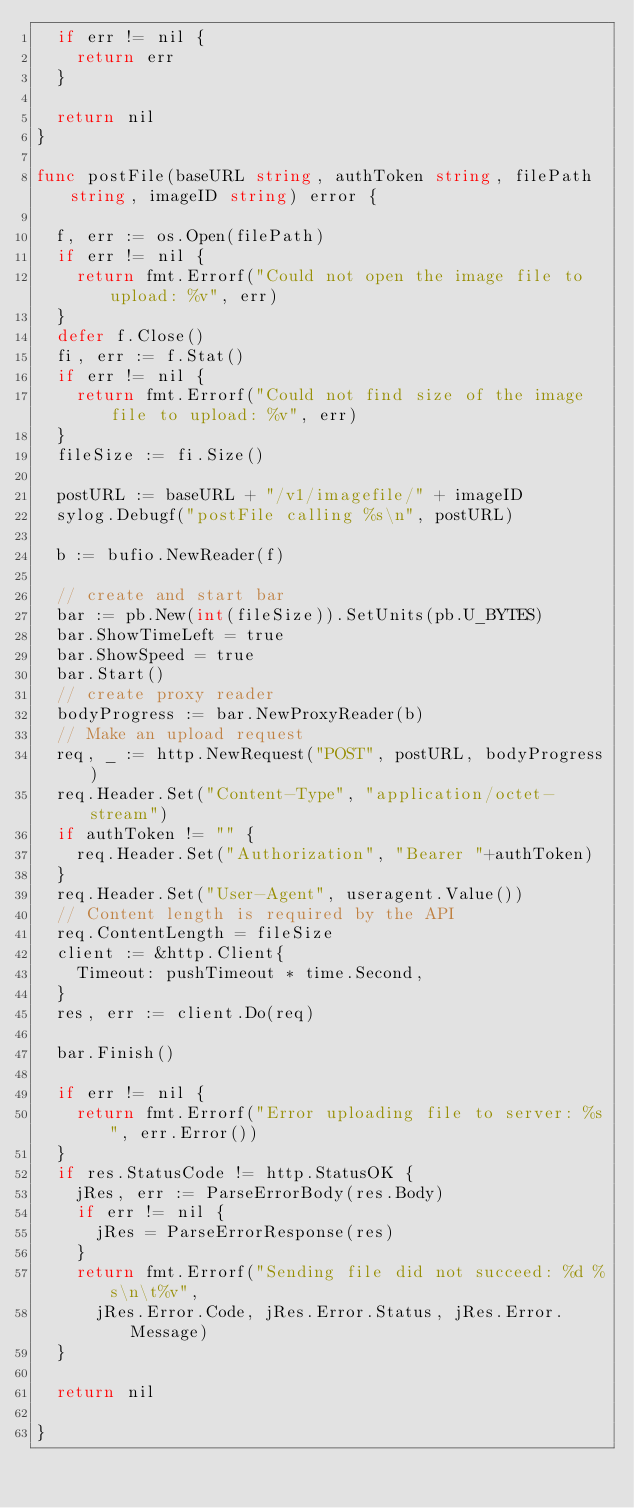<code> <loc_0><loc_0><loc_500><loc_500><_Go_>	if err != nil {
		return err
	}

	return nil
}

func postFile(baseURL string, authToken string, filePath string, imageID string) error {

	f, err := os.Open(filePath)
	if err != nil {
		return fmt.Errorf("Could not open the image file to upload: %v", err)
	}
	defer f.Close()
	fi, err := f.Stat()
	if err != nil {
		return fmt.Errorf("Could not find size of the image file to upload: %v", err)
	}
	fileSize := fi.Size()

	postURL := baseURL + "/v1/imagefile/" + imageID
	sylog.Debugf("postFile calling %s\n", postURL)

	b := bufio.NewReader(f)

	// create and start bar
	bar := pb.New(int(fileSize)).SetUnits(pb.U_BYTES)
	bar.ShowTimeLeft = true
	bar.ShowSpeed = true
	bar.Start()
	// create proxy reader
	bodyProgress := bar.NewProxyReader(b)
	// Make an upload request
	req, _ := http.NewRequest("POST", postURL, bodyProgress)
	req.Header.Set("Content-Type", "application/octet-stream")
	if authToken != "" {
		req.Header.Set("Authorization", "Bearer "+authToken)
	}
	req.Header.Set("User-Agent", useragent.Value())
	// Content length is required by the API
	req.ContentLength = fileSize
	client := &http.Client{
		Timeout: pushTimeout * time.Second,
	}
	res, err := client.Do(req)

	bar.Finish()

	if err != nil {
		return fmt.Errorf("Error uploading file to server: %s", err.Error())
	}
	if res.StatusCode != http.StatusOK {
		jRes, err := ParseErrorBody(res.Body)
		if err != nil {
			jRes = ParseErrorResponse(res)
		}
		return fmt.Errorf("Sending file did not succeed: %d %s\n\t%v",
			jRes.Error.Code, jRes.Error.Status, jRes.Error.Message)
	}

	return nil

}
</code> 